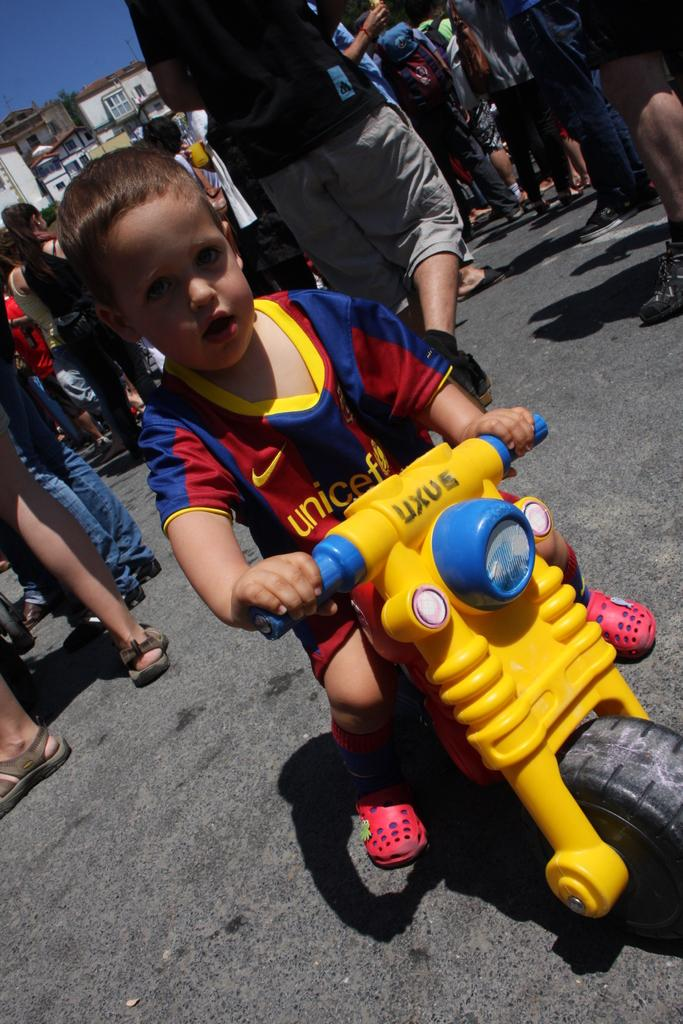Where was the image taken? The image was clicked outside. How many people are in the image? There are multiple persons in the image. Can you identify any children in the image? Yes, there is a kid among the persons. What can be seen in the background of the image? The sky is visible at the top of the image. What type of creature can be seen interacting with the clam in the image? There is no creature or clam present in the image; it features multiple persons outside. What mode of transportation is being used for the journey in the image? There is no journey or mode of transportation present in the image; it features multiple persons outside. 